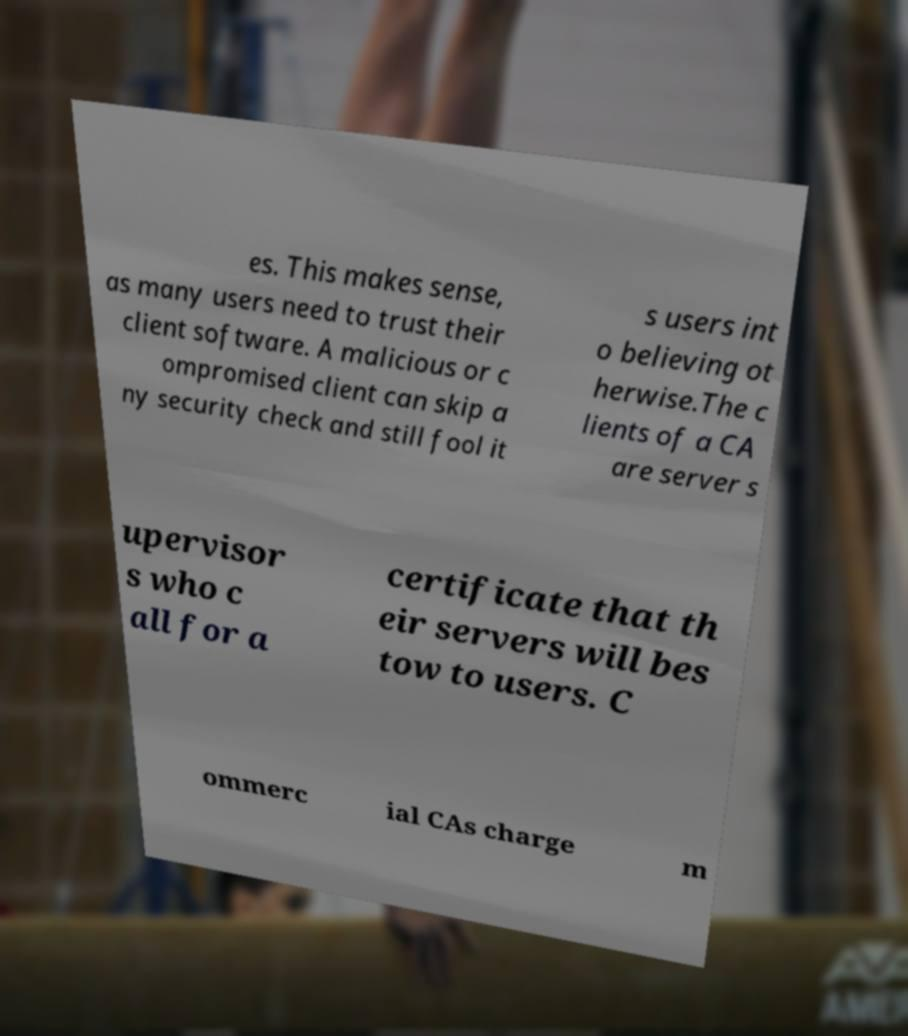Could you assist in decoding the text presented in this image and type it out clearly? es. This makes sense, as many users need to trust their client software. A malicious or c ompromised client can skip a ny security check and still fool it s users int o believing ot herwise.The c lients of a CA are server s upervisor s who c all for a certificate that th eir servers will bes tow to users. C ommerc ial CAs charge m 